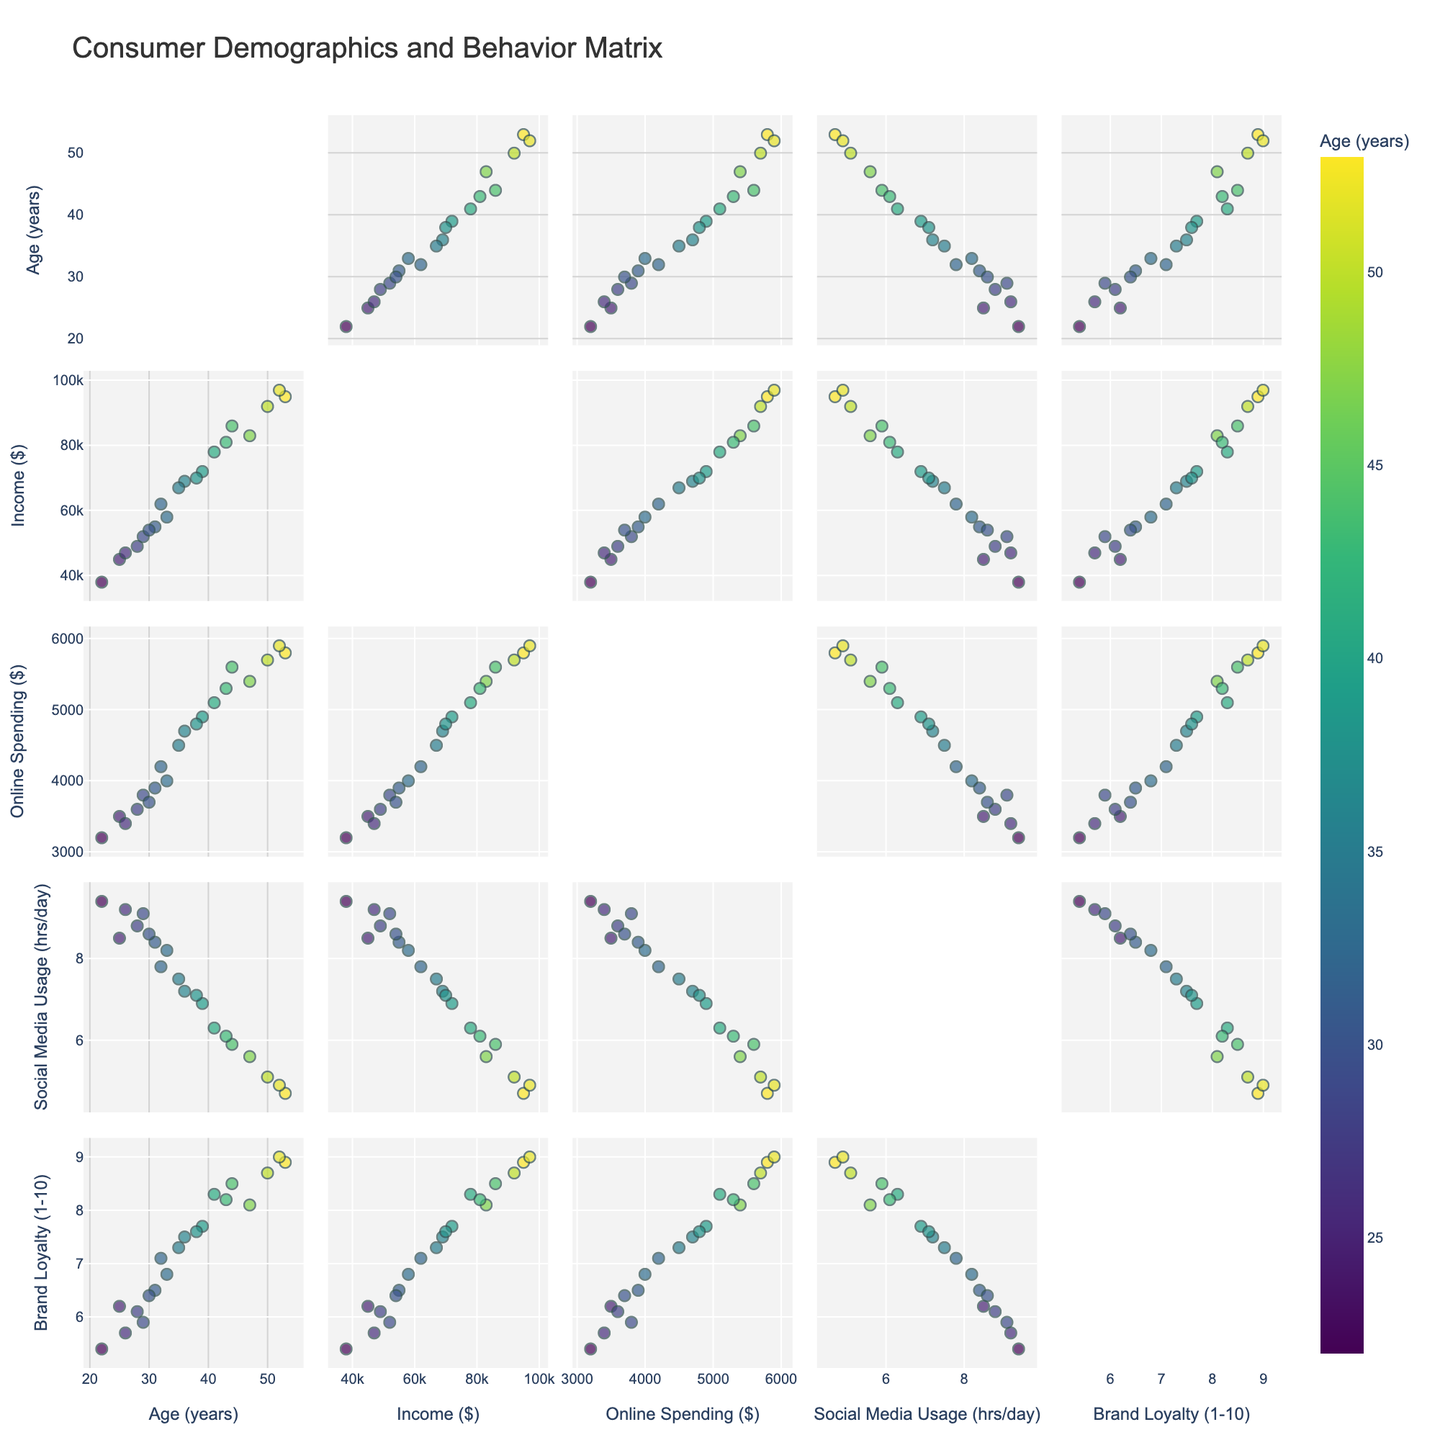How many genres are listed in the chart? Count the number of unique genre labels in the pie charts. There are 7 genre labels: Drama, Thriller, Sci-Fi, Horror, Comedy, Romance, and Action.
Answer: 7 Which genre has the highest percentage of films? Look for the genre with the largest segment in the pie chart on the left side. Drama has the highest percentage at 35%.
Answer: Drama What is the combined percentage of Sci-Fi and Horror genres? Add the percentages of Sci-Fi and Horror from the left pie chart. Sci-Fi is 15% and Horror is 10%, so 15% + 10% = 25%.
Answer: 25% How does the visual representation of percentages differ between the two pie charts? Compare the text information displayed inside the slices in the left chart to the text outside the slices in the right chart. The left chart shows percentages inside the slices, whereas the right chart shows values outside the slices.
Answer: Percentages inside vs values outside Which genres have a percentage below 10%? Identify the genre labels with segments smaller than 10% in the left pie chart. Comedy, Romance, and Action have percentages below 10%.
Answer: Comedy, Romance, Action Is the Thriller genre greater than the combined percentage of Comedy and Romance? Check the Thriller percentage, which is 25%, and compare it to the sum of Comedy (8%) and Romance (5%), which totals 13%. 25% is greater than 13%.
Answer: Yes What is the sum of the percentages for Drama, Thriller, and Sci-Fi? Add the percentages from Drama (35%), Thriller (25%), and Sci-Fi (15%). The sum is 35% + 25% + 15% = 75%.
Answer: 75% Which genre is represented by the least percentage? Identify the smallest segment in the left pie chart. Action has the smallest percentage at 2%.
Answer: Action Are there any genres with equal percentages? Look at the percentages in the left pie chart to see if any segments have the same value. No segments have equal percentages.
Answer: No 